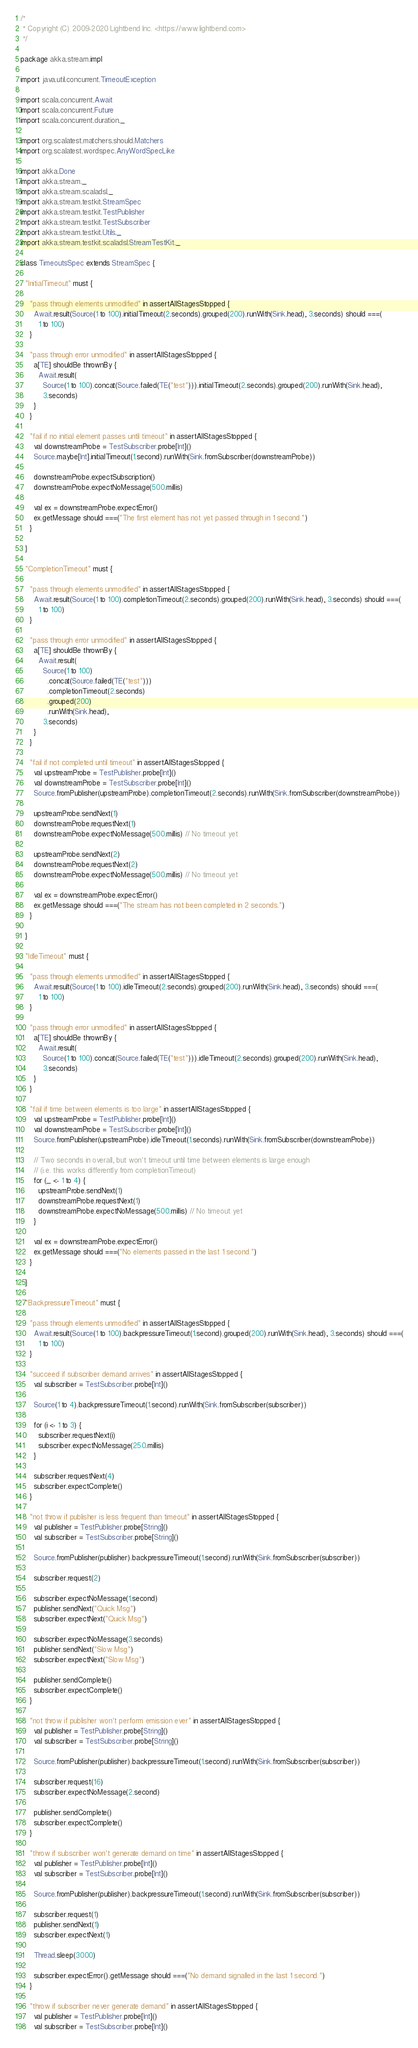<code> <loc_0><loc_0><loc_500><loc_500><_Scala_>/*
 * Copyright (C) 2009-2020 Lightbend Inc. <https://www.lightbend.com>
 */

package akka.stream.impl

import java.util.concurrent.TimeoutException

import scala.concurrent.Await
import scala.concurrent.Future
import scala.concurrent.duration._

import org.scalatest.matchers.should.Matchers
import org.scalatest.wordspec.AnyWordSpecLike

import akka.Done
import akka.stream._
import akka.stream.scaladsl._
import akka.stream.testkit.StreamSpec
import akka.stream.testkit.TestPublisher
import akka.stream.testkit.TestSubscriber
import akka.stream.testkit.Utils._
import akka.stream.testkit.scaladsl.StreamTestKit._

class TimeoutsSpec extends StreamSpec {

  "InitialTimeout" must {

    "pass through elements unmodified" in assertAllStagesStopped {
      Await.result(Source(1 to 100).initialTimeout(2.seconds).grouped(200).runWith(Sink.head), 3.seconds) should ===(
        1 to 100)
    }

    "pass through error unmodified" in assertAllStagesStopped {
      a[TE] shouldBe thrownBy {
        Await.result(
          Source(1 to 100).concat(Source.failed(TE("test"))).initialTimeout(2.seconds).grouped(200).runWith(Sink.head),
          3.seconds)
      }
    }

    "fail if no initial element passes until timeout" in assertAllStagesStopped {
      val downstreamProbe = TestSubscriber.probe[Int]()
      Source.maybe[Int].initialTimeout(1.second).runWith(Sink.fromSubscriber(downstreamProbe))

      downstreamProbe.expectSubscription()
      downstreamProbe.expectNoMessage(500.millis)

      val ex = downstreamProbe.expectError()
      ex.getMessage should ===("The first element has not yet passed through in 1 second.")
    }

  }

  "CompletionTimeout" must {

    "pass through elements unmodified" in assertAllStagesStopped {
      Await.result(Source(1 to 100).completionTimeout(2.seconds).grouped(200).runWith(Sink.head), 3.seconds) should ===(
        1 to 100)
    }

    "pass through error unmodified" in assertAllStagesStopped {
      a[TE] shouldBe thrownBy {
        Await.result(
          Source(1 to 100)
            .concat(Source.failed(TE("test")))
            .completionTimeout(2.seconds)
            .grouped(200)
            .runWith(Sink.head),
          3.seconds)
      }
    }

    "fail if not completed until timeout" in assertAllStagesStopped {
      val upstreamProbe = TestPublisher.probe[Int]()
      val downstreamProbe = TestSubscriber.probe[Int]()
      Source.fromPublisher(upstreamProbe).completionTimeout(2.seconds).runWith(Sink.fromSubscriber(downstreamProbe))

      upstreamProbe.sendNext(1)
      downstreamProbe.requestNext(1)
      downstreamProbe.expectNoMessage(500.millis) // No timeout yet

      upstreamProbe.sendNext(2)
      downstreamProbe.requestNext(2)
      downstreamProbe.expectNoMessage(500.millis) // No timeout yet

      val ex = downstreamProbe.expectError()
      ex.getMessage should ===("The stream has not been completed in 2 seconds.")
    }

  }

  "IdleTimeout" must {

    "pass through elements unmodified" in assertAllStagesStopped {
      Await.result(Source(1 to 100).idleTimeout(2.seconds).grouped(200).runWith(Sink.head), 3.seconds) should ===(
        1 to 100)
    }

    "pass through error unmodified" in assertAllStagesStopped {
      a[TE] shouldBe thrownBy {
        Await.result(
          Source(1 to 100).concat(Source.failed(TE("test"))).idleTimeout(2.seconds).grouped(200).runWith(Sink.head),
          3.seconds)
      }
    }

    "fail if time between elements is too large" in assertAllStagesStopped {
      val upstreamProbe = TestPublisher.probe[Int]()
      val downstreamProbe = TestSubscriber.probe[Int]()
      Source.fromPublisher(upstreamProbe).idleTimeout(1.seconds).runWith(Sink.fromSubscriber(downstreamProbe))

      // Two seconds in overall, but won't timeout until time between elements is large enough
      // (i.e. this works differently from completionTimeout)
      for (_ <- 1 to 4) {
        upstreamProbe.sendNext(1)
        downstreamProbe.requestNext(1)
        downstreamProbe.expectNoMessage(500.millis) // No timeout yet
      }

      val ex = downstreamProbe.expectError()
      ex.getMessage should ===("No elements passed in the last 1 second.")
    }

  }

  "BackpressureTimeout" must {

    "pass through elements unmodified" in assertAllStagesStopped {
      Await.result(Source(1 to 100).backpressureTimeout(1.second).grouped(200).runWith(Sink.head), 3.seconds) should ===(
        1 to 100)
    }

    "succeed if subscriber demand arrives" in assertAllStagesStopped {
      val subscriber = TestSubscriber.probe[Int]()

      Source(1 to 4).backpressureTimeout(1.second).runWith(Sink.fromSubscriber(subscriber))

      for (i <- 1 to 3) {
        subscriber.requestNext(i)
        subscriber.expectNoMessage(250.millis)
      }

      subscriber.requestNext(4)
      subscriber.expectComplete()
    }

    "not throw if publisher is less frequent than timeout" in assertAllStagesStopped {
      val publisher = TestPublisher.probe[String]()
      val subscriber = TestSubscriber.probe[String]()

      Source.fromPublisher(publisher).backpressureTimeout(1.second).runWith(Sink.fromSubscriber(subscriber))

      subscriber.request(2)

      subscriber.expectNoMessage(1.second)
      publisher.sendNext("Quick Msg")
      subscriber.expectNext("Quick Msg")

      subscriber.expectNoMessage(3.seconds)
      publisher.sendNext("Slow Msg")
      subscriber.expectNext("Slow Msg")

      publisher.sendComplete()
      subscriber.expectComplete()
    }

    "not throw if publisher won't perform emission ever" in assertAllStagesStopped {
      val publisher = TestPublisher.probe[String]()
      val subscriber = TestSubscriber.probe[String]()

      Source.fromPublisher(publisher).backpressureTimeout(1.second).runWith(Sink.fromSubscriber(subscriber))

      subscriber.request(16)
      subscriber.expectNoMessage(2.second)

      publisher.sendComplete()
      subscriber.expectComplete()
    }

    "throw if subscriber won't generate demand on time" in assertAllStagesStopped {
      val publisher = TestPublisher.probe[Int]()
      val subscriber = TestSubscriber.probe[Int]()

      Source.fromPublisher(publisher).backpressureTimeout(1.second).runWith(Sink.fromSubscriber(subscriber))

      subscriber.request(1)
      publisher.sendNext(1)
      subscriber.expectNext(1)

      Thread.sleep(3000)

      subscriber.expectError().getMessage should ===("No demand signalled in the last 1 second.")
    }

    "throw if subscriber never generate demand" in assertAllStagesStopped {
      val publisher = TestPublisher.probe[Int]()
      val subscriber = TestSubscriber.probe[Int]()
</code> 